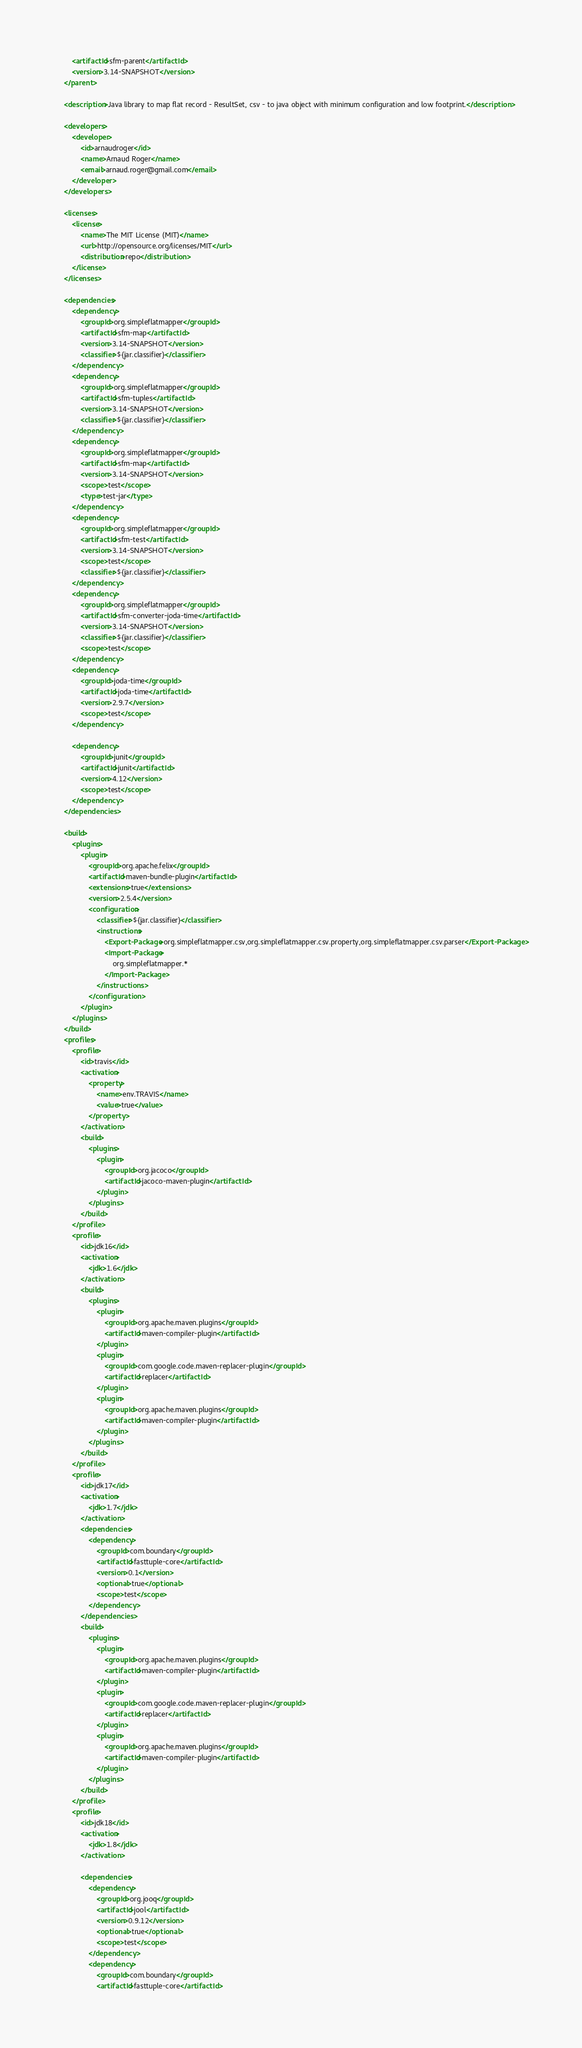<code> <loc_0><loc_0><loc_500><loc_500><_XML_>		<artifactId>sfm-parent</artifactId>
		<version>3.14-SNAPSHOT</version>
	</parent>

	<description>Java library to map flat record - ResultSet, csv - to java object with minimum configuration and low footprint.</description>

	<developers>
		<developer>
			<id>arnaudroger</id>
			<name>Arnaud Roger</name>
			<email>arnaud.roger@gmail.com</email>
		</developer>
	</developers>

	<licenses>
		<license>
			<name>The MIT License (MIT)</name>
			<url>http://opensource.org/licenses/MIT</url>
			<distribution>repo</distribution>
		</license>
	</licenses>

	<dependencies>
		<dependency>
			<groupId>org.simpleflatmapper</groupId>
			<artifactId>sfm-map</artifactId>
			<version>3.14-SNAPSHOT</version>
			<classifier>${jar.classifier}</classifier>
		</dependency>
		<dependency>
			<groupId>org.simpleflatmapper</groupId>
			<artifactId>sfm-tuples</artifactId>
			<version>3.14-SNAPSHOT</version>
			<classifier>${jar.classifier}</classifier>
		</dependency>
		<dependency>
			<groupId>org.simpleflatmapper</groupId>
			<artifactId>sfm-map</artifactId>
			<version>3.14-SNAPSHOT</version>
			<scope>test</scope>
			<type>test-jar</type>
		</dependency>
        <dependency>
            <groupId>org.simpleflatmapper</groupId>
            <artifactId>sfm-test</artifactId>
            <version>3.14-SNAPSHOT</version>
            <scope>test</scope>
			<classifier>${jar.classifier}</classifier>
		</dependency>
		<dependency>
			<groupId>org.simpleflatmapper</groupId>
			<artifactId>sfm-converter-joda-time</artifactId>
			<version>3.14-SNAPSHOT</version>
			<classifier>${jar.classifier}</classifier>
			<scope>test</scope>
		</dependency>
		<dependency>
			<groupId>joda-time</groupId>
			<artifactId>joda-time</artifactId>
			<version>2.9.7</version>
			<scope>test</scope>
		</dependency>

		<dependency>
			<groupId>junit</groupId>
			<artifactId>junit</artifactId>
			<version>4.12</version>
			<scope>test</scope>
		</dependency>
    </dependencies>

	<build>
		<plugins>
			<plugin>
				<groupId>org.apache.felix</groupId>
				<artifactId>maven-bundle-plugin</artifactId>
				<extensions>true</extensions>
				<version>2.5.4</version>
				<configuration>
					<classifier>${jar.classifier}</classifier>
					<instructions>
						<Export-Package>org.simpleflatmapper.csv,org.simpleflatmapper.csv.property,org.simpleflatmapper.csv.parser</Export-Package>
						<Import-Package>
							org.simpleflatmapper.*
						</Import-Package>
					</instructions>
				</configuration>
			</plugin>
		</plugins>
	</build>
	<profiles>
		<profile>
			<id>travis</id>
			<activation>
				<property>
					<name>env.TRAVIS</name>
					<value>true</value>
				</property>
			</activation>
			<build>
				<plugins>
					<plugin>
						<groupId>org.jacoco</groupId>
						<artifactId>jacoco-maven-plugin</artifactId>
					</plugin>
				</plugins>
			</build>
		</profile>
		<profile>
			<id>jdk16</id>
			<activation>
				<jdk>1.6</jdk>
			</activation>
			<build>
				<plugins>
					<plugin>
						<groupId>org.apache.maven.plugins</groupId>
						<artifactId>maven-compiler-plugin</artifactId>
					</plugin>
					<plugin>
						<groupId>com.google.code.maven-replacer-plugin</groupId>
						<artifactId>replacer</artifactId>
					</plugin>
					<plugin>
						<groupId>org.apache.maven.plugins</groupId>
						<artifactId>maven-compiler-plugin</artifactId>
					</plugin>
				</plugins>
			</build>
		</profile>
		<profile>
			<id>jdk17</id>
			<activation>
				<jdk>1.7</jdk>
			</activation>
			<dependencies>
				<dependency>
					<groupId>com.boundary</groupId>
					<artifactId>fasttuple-core</artifactId>
					<version>0.1</version>
					<optional>true</optional>
					<scope>test</scope>
				</dependency>
			</dependencies>
			<build>
				<plugins>
					<plugin>
						<groupId>org.apache.maven.plugins</groupId>
						<artifactId>maven-compiler-plugin</artifactId>
					</plugin>
					<plugin>
						<groupId>com.google.code.maven-replacer-plugin</groupId>
						<artifactId>replacer</artifactId>
					</plugin>
					<plugin>
						<groupId>org.apache.maven.plugins</groupId>
						<artifactId>maven-compiler-plugin</artifactId>
					</plugin>
				</plugins>
			</build>
		</profile>
		<profile>
			<id>jdk18</id>
			<activation>
				<jdk>1.8</jdk>
			</activation>

			<dependencies>
				<dependency>
					<groupId>org.jooq</groupId>
					<artifactId>jool</artifactId>
					<version>0.9.12</version>
					<optional>true</optional>
					<scope>test</scope>
				</dependency>
				<dependency>
					<groupId>com.boundary</groupId>
					<artifactId>fasttuple-core</artifactId></code> 